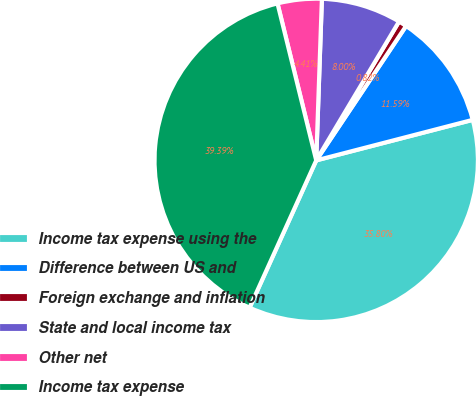Convert chart. <chart><loc_0><loc_0><loc_500><loc_500><pie_chart><fcel>Income tax expense using the<fcel>Difference between US and<fcel>Foreign exchange and inflation<fcel>State and local income tax<fcel>Other net<fcel>Income tax expense<nl><fcel>35.8%<fcel>11.59%<fcel>0.82%<fcel>8.0%<fcel>4.41%<fcel>39.39%<nl></chart> 